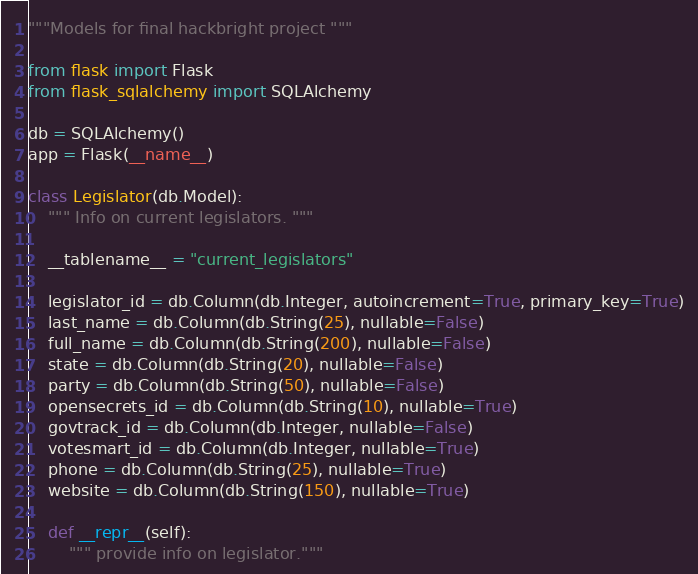<code> <loc_0><loc_0><loc_500><loc_500><_Python_>"""Models for final hackbright project """

from flask import Flask
from flask_sqlalchemy import SQLAlchemy

db = SQLAlchemy()
app = Flask(__name__)

class Legislator(db.Model):
    """ Info on current legislators. """

    __tablename__ = "current_legislators"

    legislator_id = db.Column(db.Integer, autoincrement=True, primary_key=True)
    last_name = db.Column(db.String(25), nullable=False)
    full_name = db.Column(db.String(200), nullable=False)
    state = db.Column(db.String(20), nullable=False)
    party = db.Column(db.String(50), nullable=False)
    opensecrets_id = db.Column(db.String(10), nullable=True)
    govtrack_id = db.Column(db.Integer, nullable=False)
    votesmart_id = db.Column(db.Integer, nullable=True)
    phone = db.Column(db.String(25), nullable=True)
    website = db.Column(db.String(150), nullable=True)

    def __repr__(self):
        """ provide info on legislator."""
</code> 